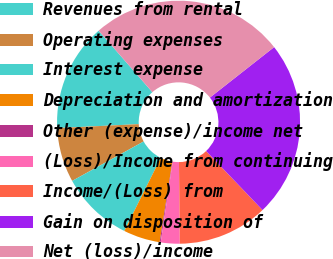Convert chart to OTSL. <chart><loc_0><loc_0><loc_500><loc_500><pie_chart><fcel>Revenues from rental<fcel>Operating expenses<fcel>Interest expense<fcel>Depreciation and amortization<fcel>Other (expense)/income net<fcel>(Loss)/Income from continuing<fcel>Income/(Loss) from<fcel>Gain on disposition of<fcel>Net (loss)/income<nl><fcel>14.35%<fcel>7.25%<fcel>9.61%<fcel>4.88%<fcel>0.14%<fcel>2.51%<fcel>11.98%<fcel>23.46%<fcel>25.82%<nl></chart> 